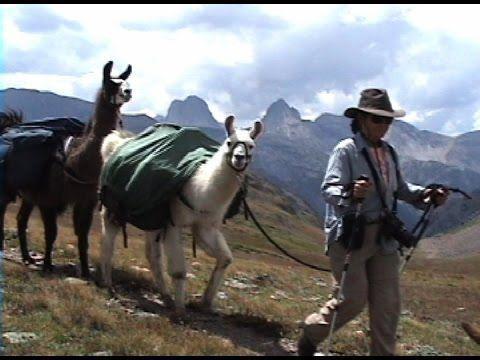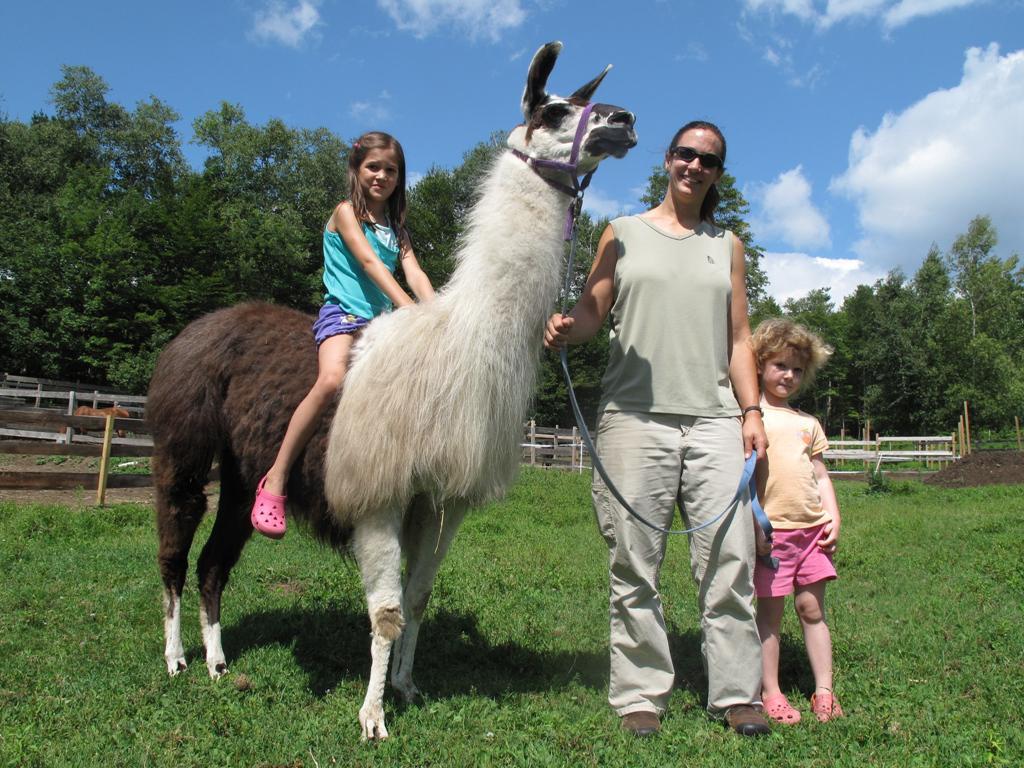The first image is the image on the left, the second image is the image on the right. Examine the images to the left and right. Is the description "All the llamas have leashes." accurate? Answer yes or no. Yes. The first image is the image on the left, the second image is the image on the right. Evaluate the accuracy of this statement regarding the images: "A woman in a tank top is standing to the right of a llama and holding a blue rope attached to its harness.". Is it true? Answer yes or no. Yes. 